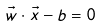<formula> <loc_0><loc_0><loc_500><loc_500>\vec { w } \cdot \vec { x } - b = 0</formula> 